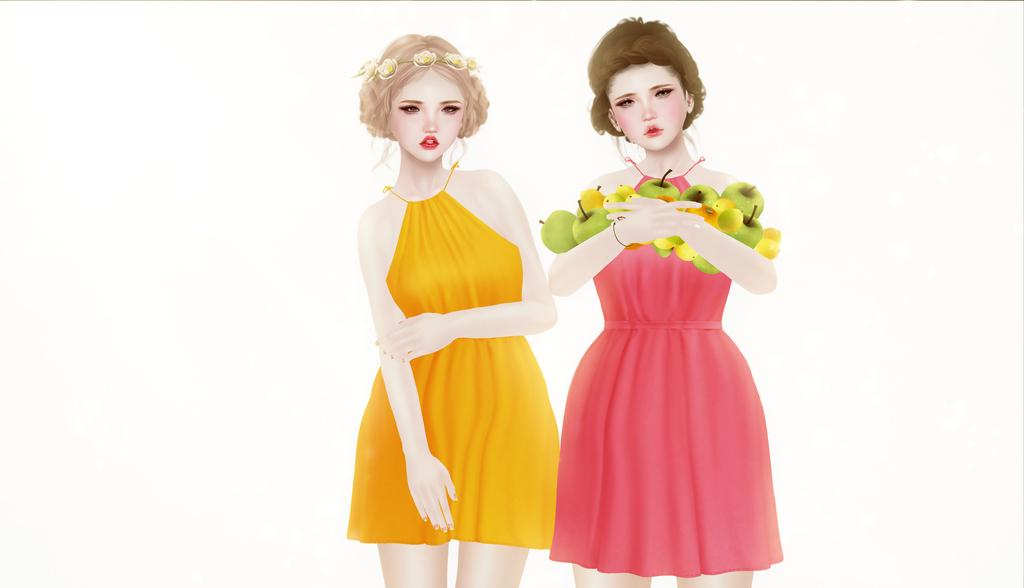What type of image is being described? The image is animated. How many people are present in the image? There are two ladies in the image. What is one of the ladies doing in the image? One of the ladies is holding fruits in her hands. What type of payment method is being used by the ladies in the image? There is no payment method visible in the image, as it only shows two ladies and one of them holding fruits. --- Facts: 1. There is a car in the image. 2. The car is parked on the street. 3. There are trees in the background of the image. 4. The sky is visible in the image. Absurd Topics: parrot, bicycle, ocean Conversation: What is the main subject of the image? The main subject of the image is a car. Where is the car located in the image? The car is parked on the street. What can be seen in the background of the image? There are trees in the background of the image. What is visible at the top of the image? The sky is visible in the image. Reasoning: Let's think step by step in order to produce the conversation. We start by identifying the main subject of the image, which is the car. Then, we describe the car's location and the surrounding environment, including the trees in the background and the sky visible at the top of the image. We ensure that each question can be answered definitively with the information given and avoid yes/no questions. Absurd Question/Answer: Can you see a parrot perched on the car in the image? No, there is no parrot present in the image. Is the car parked near an ocean in the image? No, the image does not show an ocean or any body of water. 